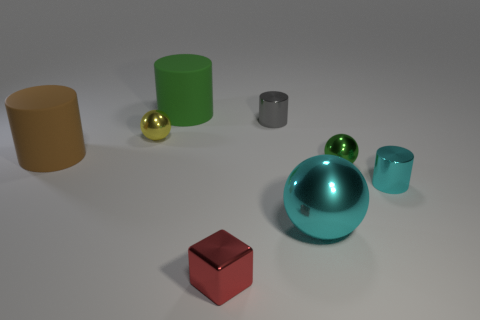Add 1 small gray objects. How many objects exist? 9 Subtract all large brown matte cylinders. Subtract all big cyan balls. How many objects are left? 6 Add 3 metallic objects. How many metallic objects are left? 9 Add 6 brown cylinders. How many brown cylinders exist? 7 Subtract 0 purple cubes. How many objects are left? 8 Subtract all cubes. How many objects are left? 7 